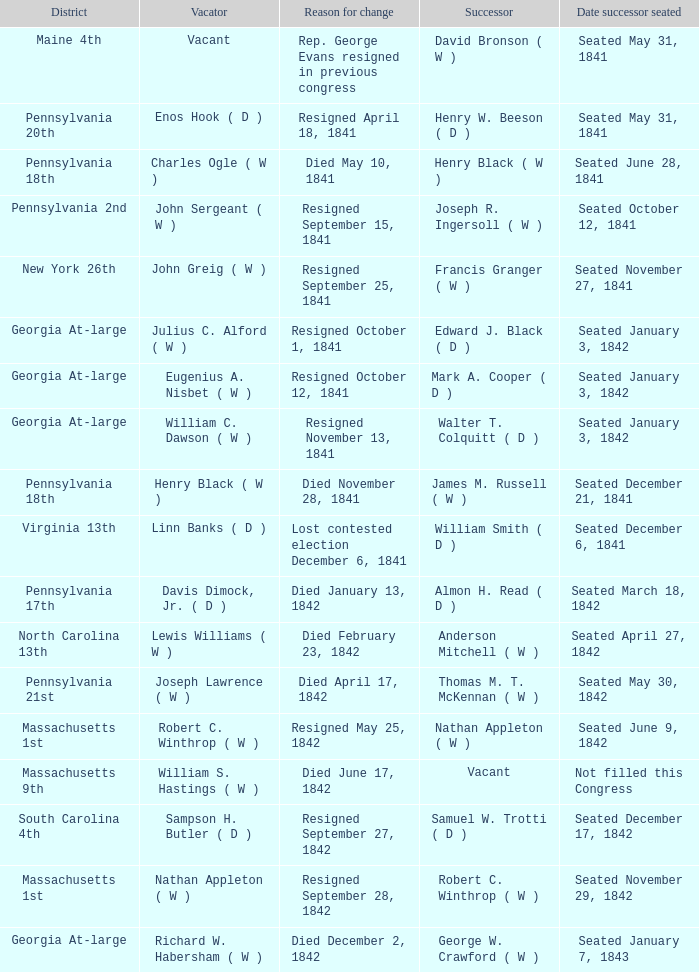Name the successor for north carolina 13th Anderson Mitchell ( W ). 